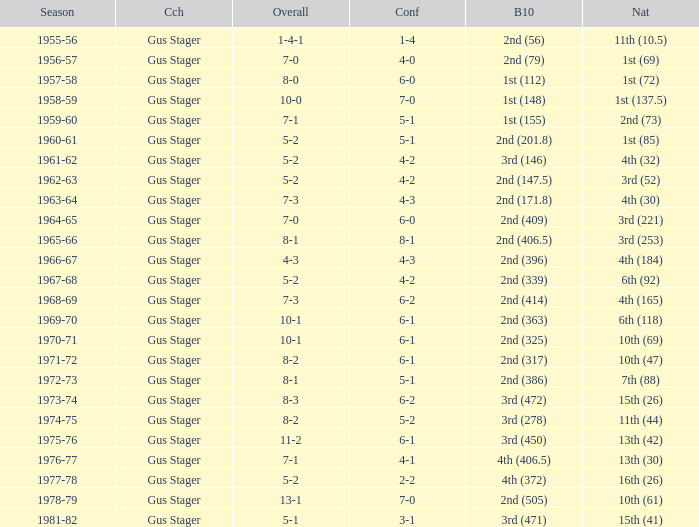What is the Coach with a Big Ten that is 3rd (278)? Gus Stager. 